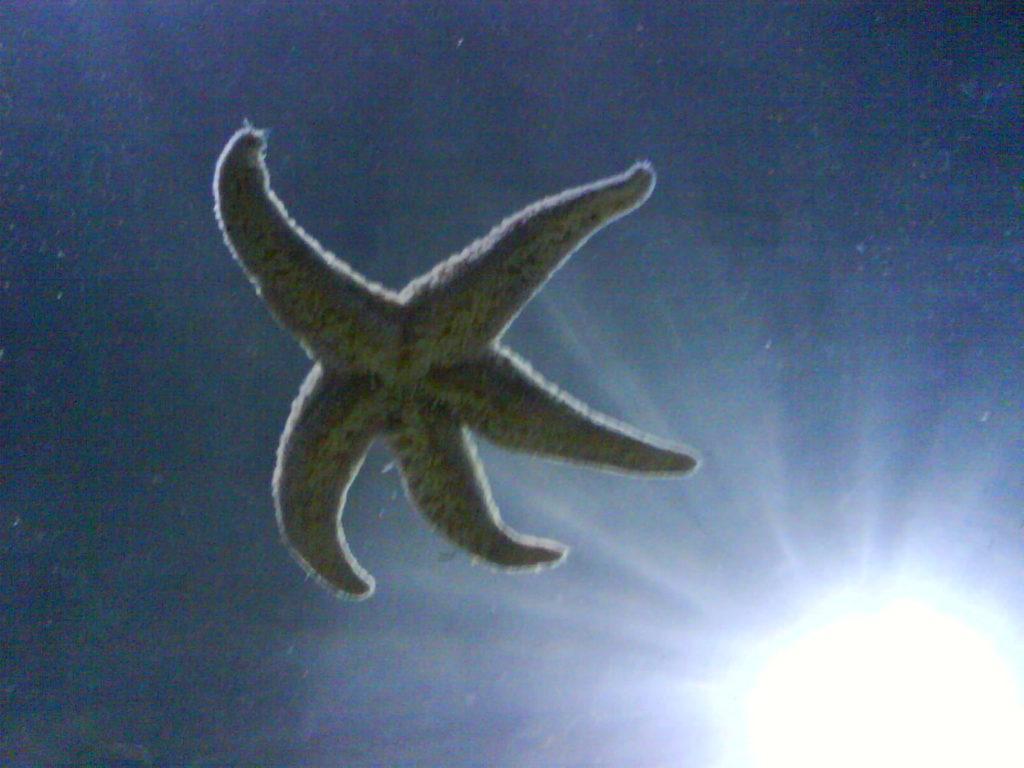In one or two sentences, can you explain what this image depicts? In this image we can see there is a starfish behind that there is a light. 